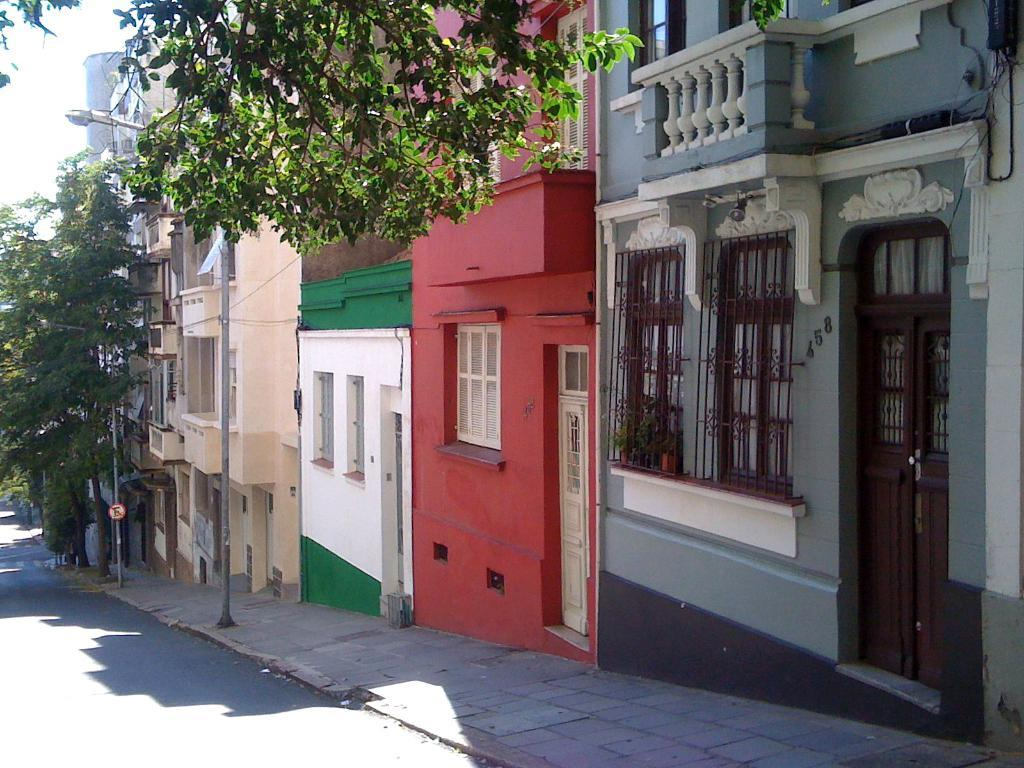What is located at the bottom left side of the image? There is a road at the bottom left side of the image. What can be seen in the background of the image? There are trees, boards on poles, buildings, windows, doors, and objects on the wall in the background of the image. What part of the natural environment is visible in the image? The sky is visible in the background of the image. How much toothpaste is on the leaf in the image? There is no toothpaste or leaf present in the image. 